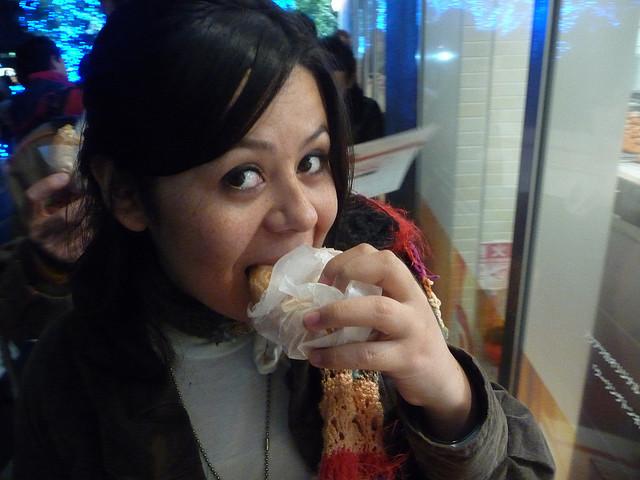Is this a women?
Keep it brief. Yes. Is the woman wearing ear muffs?
Write a very short answer. No. Is there someone behind the female?
Short answer required. Yes. 